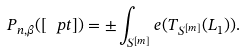<formula> <loc_0><loc_0><loc_500><loc_500>P _ { n , \beta } ( [ \ p t ] ) = \pm \int _ { S ^ { [ m ] } } e ( T _ { S ^ { [ m ] } } ( L _ { 1 } ) ) .</formula> 